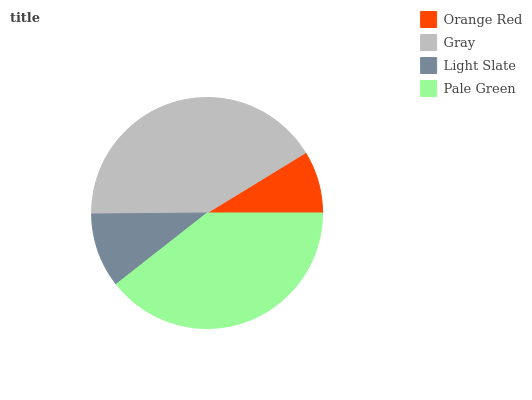Is Orange Red the minimum?
Answer yes or no. Yes. Is Gray the maximum?
Answer yes or no. Yes. Is Light Slate the minimum?
Answer yes or no. No. Is Light Slate the maximum?
Answer yes or no. No. Is Gray greater than Light Slate?
Answer yes or no. Yes. Is Light Slate less than Gray?
Answer yes or no. Yes. Is Light Slate greater than Gray?
Answer yes or no. No. Is Gray less than Light Slate?
Answer yes or no. No. Is Pale Green the high median?
Answer yes or no. Yes. Is Light Slate the low median?
Answer yes or no. Yes. Is Orange Red the high median?
Answer yes or no. No. Is Orange Red the low median?
Answer yes or no. No. 